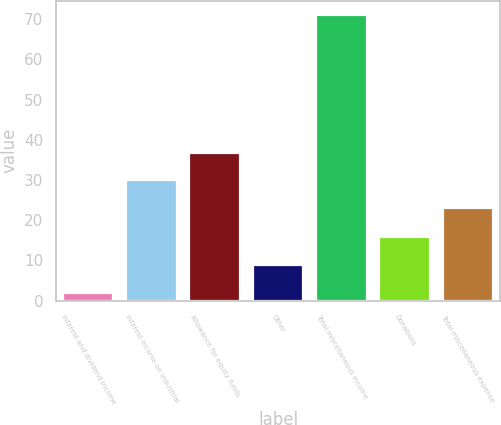<chart> <loc_0><loc_0><loc_500><loc_500><bar_chart><fcel>Interest and dividend income<fcel>Interest income on industrial<fcel>Allowance for equity funds<fcel>Other<fcel>Total miscellaneous income<fcel>Donations<fcel>Total miscellaneous expense<nl><fcel>2<fcel>29.9<fcel>36.8<fcel>8.9<fcel>71<fcel>15.8<fcel>23<nl></chart> 